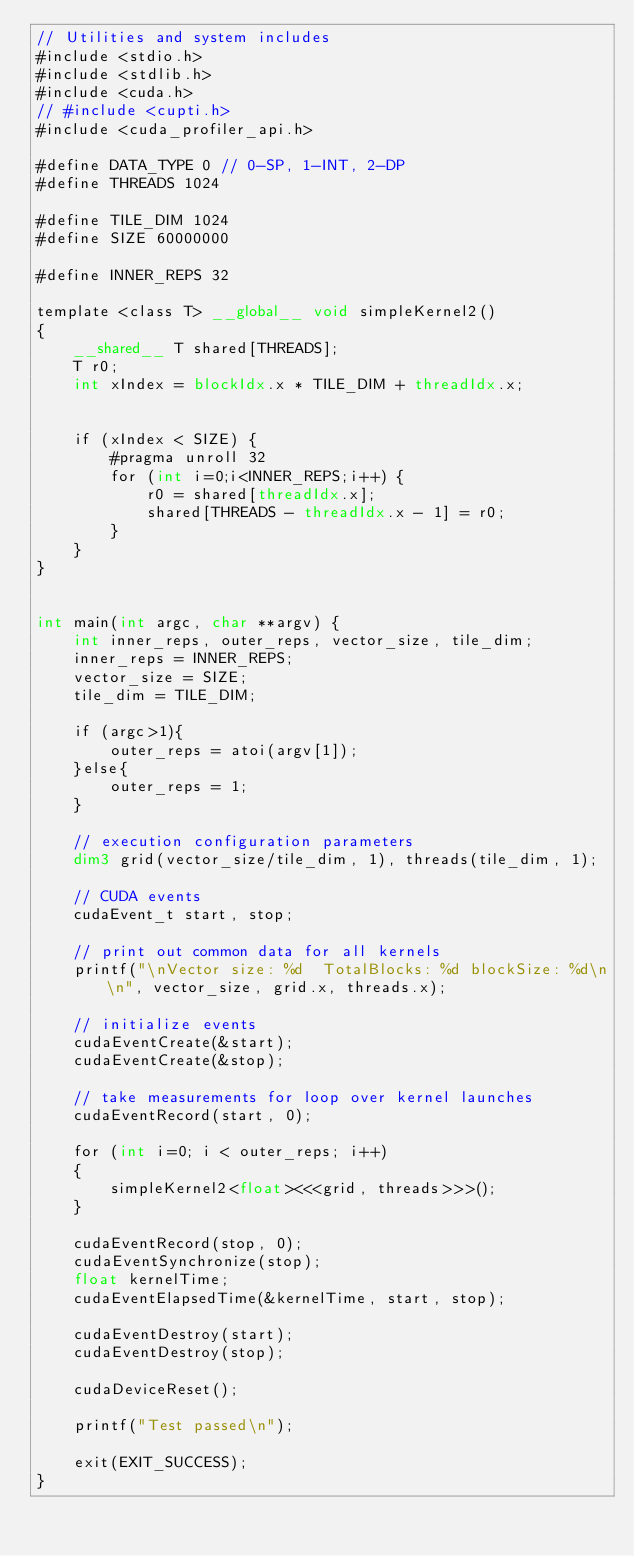Convert code to text. <code><loc_0><loc_0><loc_500><loc_500><_Cuda_>// Utilities and system includes
#include <stdio.h>
#include <stdlib.h>
#include <cuda.h>
// #include <cupti.h>
#include <cuda_profiler_api.h>

#define DATA_TYPE 0 // 0-SP, 1-INT, 2-DP
#define THREADS 1024

#define TILE_DIM 1024
#define SIZE 60000000

#define INNER_REPS 32

template <class T> __global__ void simpleKernel2()
{
    __shared__ T shared[THREADS];
    T r0;
    int xIndex = blockIdx.x * TILE_DIM + threadIdx.x;


    if (xIndex < SIZE) {
        #pragma unroll 32
        for (int i=0;i<INNER_REPS;i++) {
            r0 = shared[threadIdx.x];
            shared[THREADS - threadIdx.x - 1] = r0;
        }
    }
}


int main(int argc, char **argv) {
    int inner_reps, outer_reps, vector_size, tile_dim;
    inner_reps = INNER_REPS;
    vector_size = SIZE;
    tile_dim = TILE_DIM;

    if (argc>1){
        outer_reps = atoi(argv[1]);
    }else{
        outer_reps = 1;
    }

    // execution configuration parameters
    dim3 grid(vector_size/tile_dim, 1), threads(tile_dim, 1);

    // CUDA events
    cudaEvent_t start, stop;

    // print out common data for all kernels
    printf("\nVector size: %d  TotalBlocks: %d blockSize: %d\n\n", vector_size, grid.x, threads.x);

    // initialize events
    cudaEventCreate(&start);
    cudaEventCreate(&stop);

    // take measurements for loop over kernel launches
    cudaEventRecord(start, 0);

    for (int i=0; i < outer_reps; i++)
    {
        simpleKernel2<float><<<grid, threads>>>();
    }

    cudaEventRecord(stop, 0);
    cudaEventSynchronize(stop);
    float kernelTime;
    cudaEventElapsedTime(&kernelTime, start, stop);

    cudaEventDestroy(start);
    cudaEventDestroy(stop);

    cudaDeviceReset();

    printf("Test passed\n");

    exit(EXIT_SUCCESS);
}
</code> 